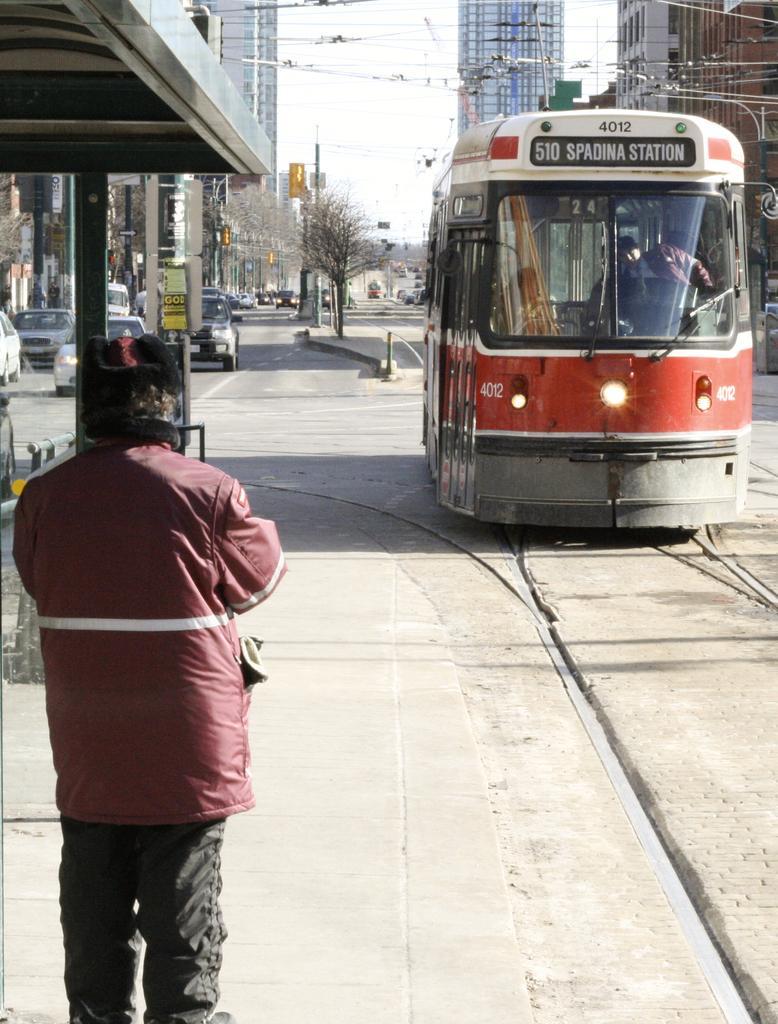Can you describe this image briefly? In the image there is a train on the right side and a man standing on left side, in the back there are few cars going on the road followed by buildings on either side and above its sky. 